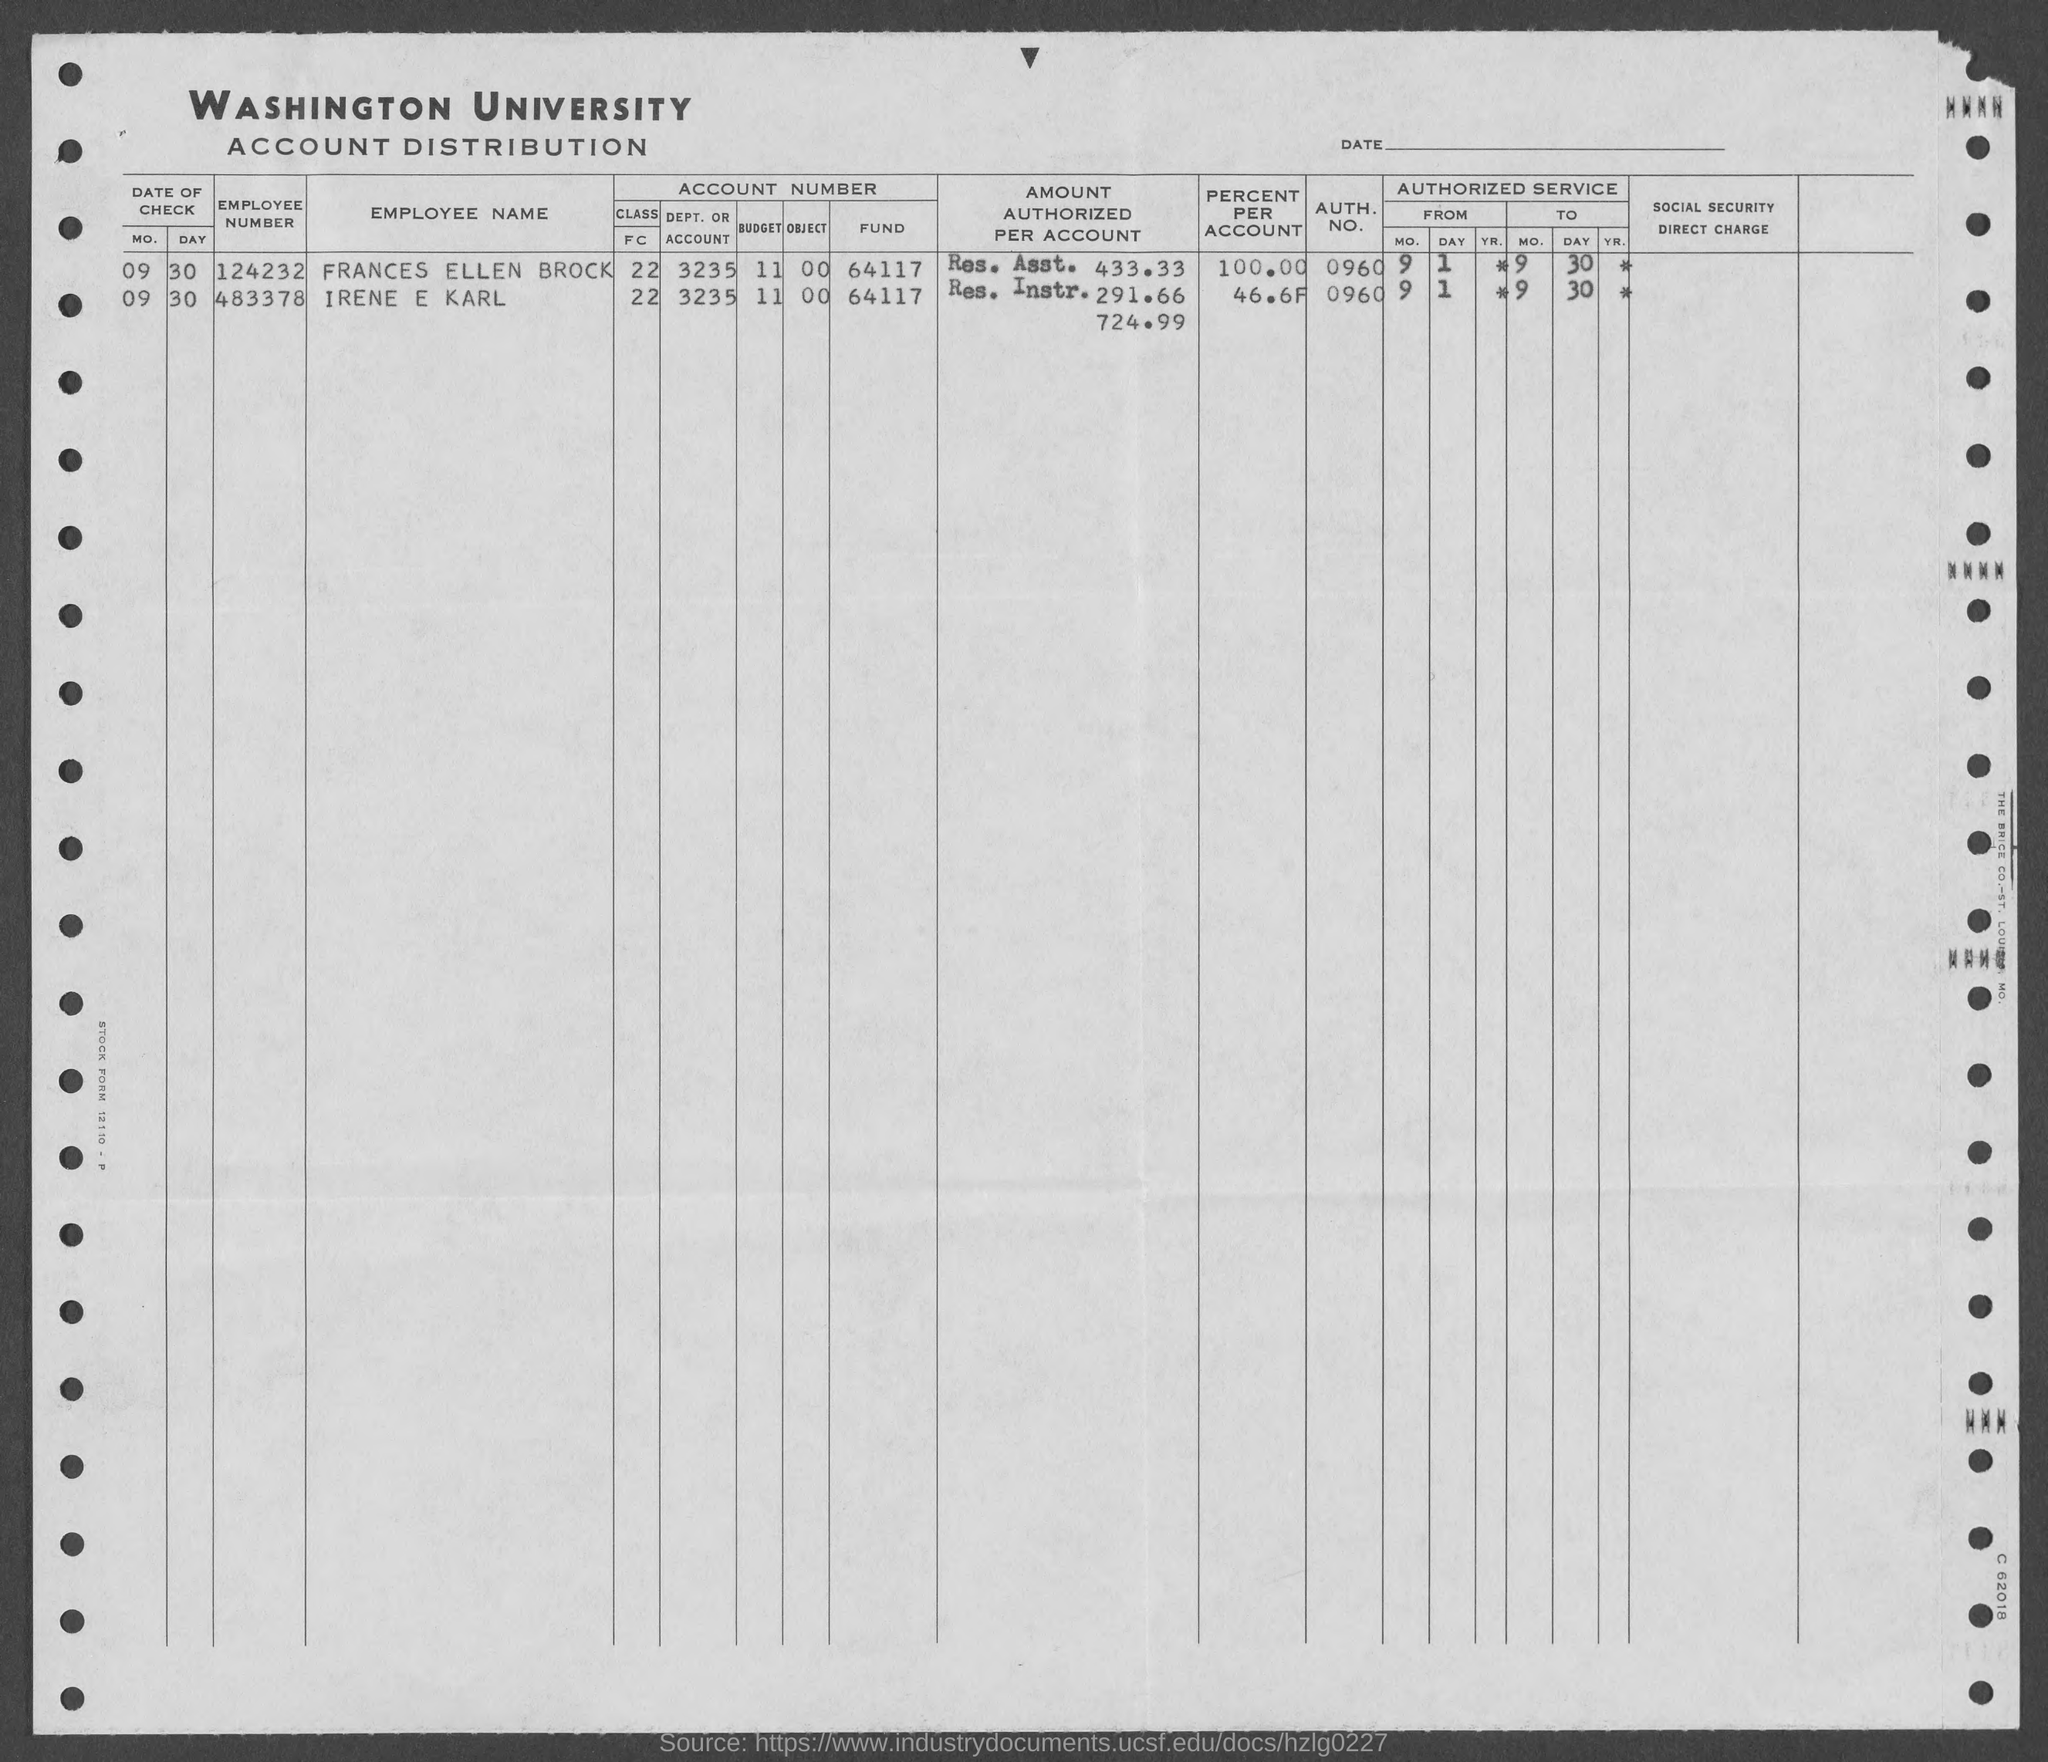What is the emp. no. of frances ellen brock ?
Make the answer very short. 124232. What is the emp. no. of irene e karl?
Your answer should be very brief. 483378. What is the auth. no. of frances ellen brock?
Your answer should be compact. 0960. What is the auth. no. of irene e  karl ?
Your answer should be compact. 0960. 